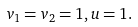Convert formula to latex. <formula><loc_0><loc_0><loc_500><loc_500>v _ { 1 } = v _ { 2 } = 1 , u = 1 .</formula> 